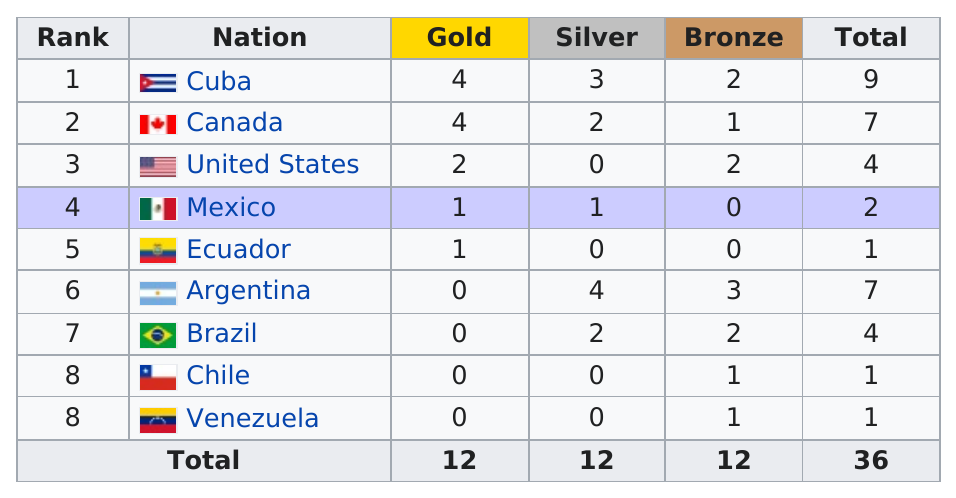Indicate a few pertinent items in this graphic. Brazil did not have more silver medals than Cuba. In fact, Cuba had more silver medals. Ecuador is the only nation to have won a gold medal and no other medals at any Olympic games. In total, there were 36 medals awarded. Argentina won a total of 7 medals in the games. Mexico ranks fourth in the current ranking. 